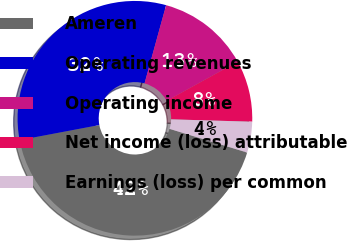<chart> <loc_0><loc_0><loc_500><loc_500><pie_chart><fcel>Ameren<fcel>Operating revenues<fcel>Operating income<fcel>Net income (loss) attributable<fcel>Earnings (loss) per common<nl><fcel>42.31%<fcel>32.26%<fcel>12.7%<fcel>8.48%<fcel>4.25%<nl></chart> 